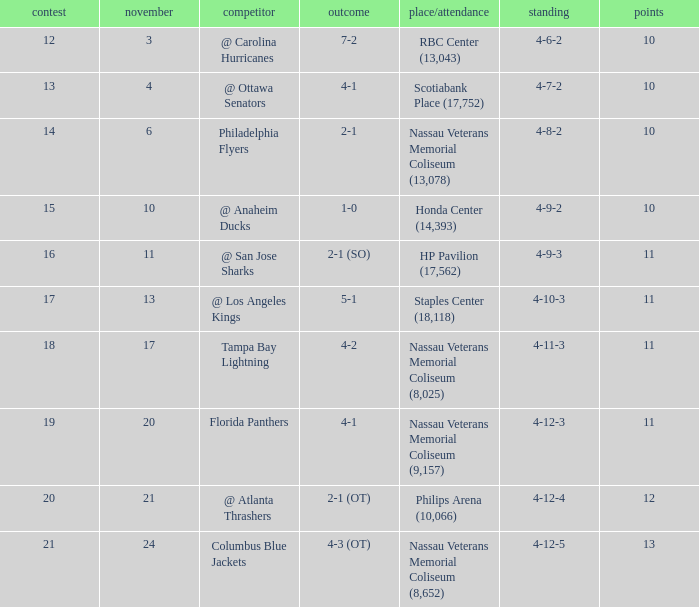What is the least entry for game if the score is 1-0? 15.0. 